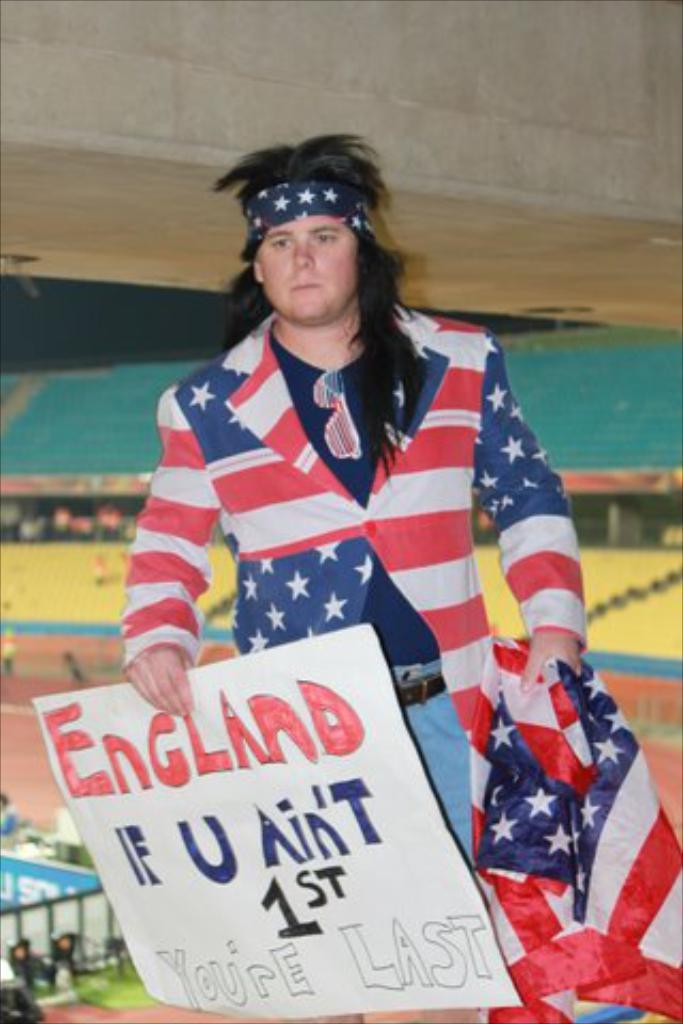What country does this person likely support?
Keep it short and to the point. England. 